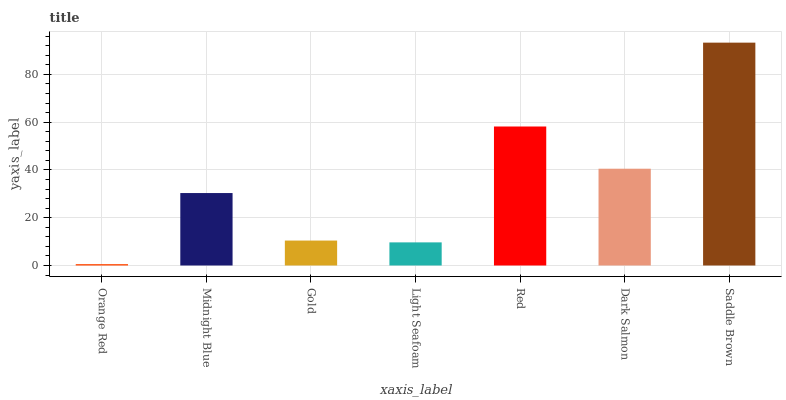Is Orange Red the minimum?
Answer yes or no. Yes. Is Saddle Brown the maximum?
Answer yes or no. Yes. Is Midnight Blue the minimum?
Answer yes or no. No. Is Midnight Blue the maximum?
Answer yes or no. No. Is Midnight Blue greater than Orange Red?
Answer yes or no. Yes. Is Orange Red less than Midnight Blue?
Answer yes or no. Yes. Is Orange Red greater than Midnight Blue?
Answer yes or no. No. Is Midnight Blue less than Orange Red?
Answer yes or no. No. Is Midnight Blue the high median?
Answer yes or no. Yes. Is Midnight Blue the low median?
Answer yes or no. Yes. Is Saddle Brown the high median?
Answer yes or no. No. Is Orange Red the low median?
Answer yes or no. No. 